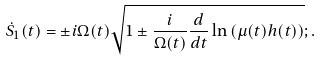<formula> <loc_0><loc_0><loc_500><loc_500>\dot { S } _ { 1 } ( t ) = \pm i \Omega ( t ) \sqrt { 1 \pm \frac { i } { \Omega ( t ) } \frac { d } { d t } \ln \left ( \mu ( t ) h ( t ) \right ) } ; .</formula> 